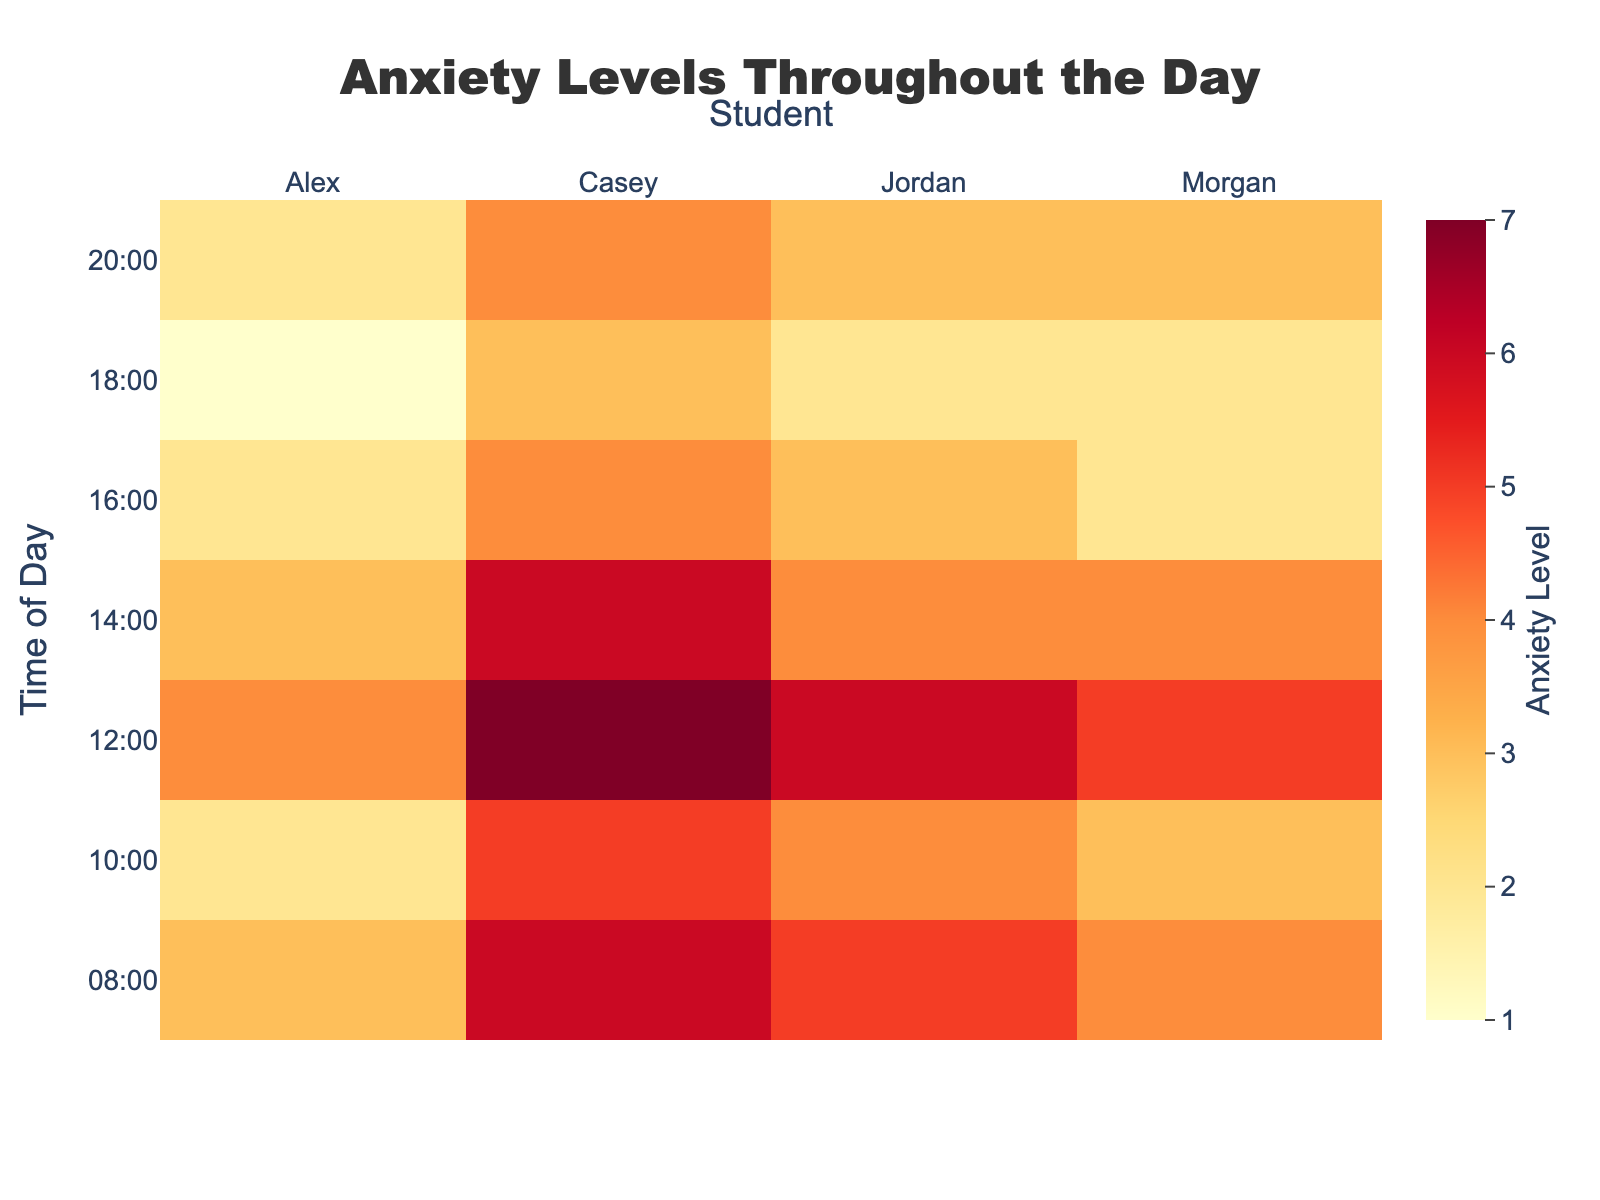What's the title of the heatmap? The title is displayed at the top of the heatmap, usually in a larger and bolder font. It provides an overview or the main subject of the plot.
Answer: Anxiety Levels Throughout the Day What color represents the highest anxiety level? The highest level of anxiety is represented by the most intense color in the heatmap. By examining the color gradient, we can identify the color that corresponds to the most extreme value.
Answer: A deep red shade At what times of day does Alex experience a drop in anxiety levels? By looking at Alex's anxiety levels across different times of the day, we observe where his scores decrease. Compare the values from previous times to identify dips.
Answer: 10:00, 16:00, and 18:00 Who has the highest anxiety level at 12:00? Find the row corresponding to 12:00 and identify the highest number in that row along with the corresponding student’s name.
Answer: Casey What is the average anxiety level of Morgan throughout the day? Calculate the sum of Morgan's anxiety levels at all times and then divide by the number of time points to get the average. (4+3+5+4+2+2+3 = 23, 23/7 ≈ 3.29)
Answer: Approximately 3.29 Who experienced the most consistent anxiety levels throughout the day? Look for the student whose anxiety scores vary the least across different times of the day by examining the relative constancy in their values.
Answer: Morgan How do Jordan’s anxiety levels at 08:00 compare to those at 18:00? Compare the two values from Jordan's columns at 08:00 and 18:00 to see if there is an increase, decrease, or if they remain the same.
Answer: 08:00 is 5 while 18:00 is 2, showing a decrease At which time of day is the overall anxiety level highest for the group of students? Sum the anxiety levels of all students for each time point and identify the time with the highest total. (08:00: 18, 10:00: 14, 12:00: 22, 14:00: 17, 16:00: 11, 18:00: 8, 20:00: 12)
Answer: 12:00 How does Casey's average anxiety level compare to the group's average anxiety level? Calculate Casey’s average ( (6+5+7+6+4+3+4)/7 = 5) and the group’s average ( (3+5+4+6+2+4+3+5+4+6+5+7+3+4+4+6+2+3+2+4+1+2+2+3+2+3+3+4)/28 ≈ 4.07).
Answer: Casey's is 5 and the group's is approximately 4.07 